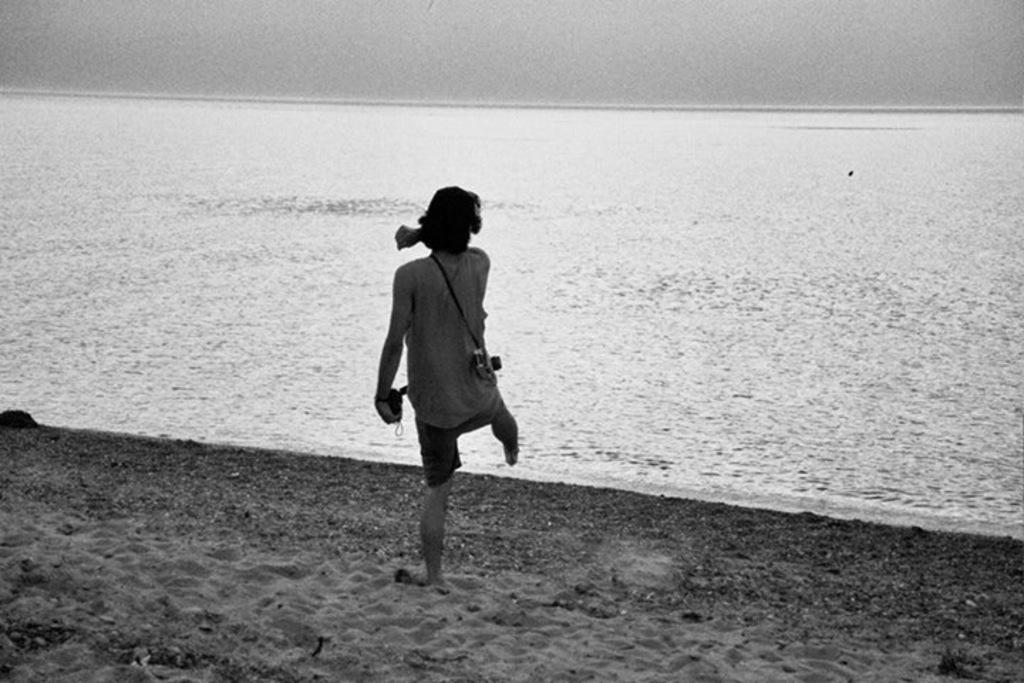What is the main subject in the foreground of the image? There is a man in the foreground of the image. What is the man wearing? The man is wearing a camera. What is the man holding in the image? The man is holding an object. How is the man positioned in the image? The man is standing on one foot. What type of surface is the man standing on? The man is standing on sand. What can be seen in the background of the image? There is water in the background of the image. What type of iron can be seen in the image? There is no iron present in the image. Can you tell me what receipt the man is holding in the image? The man is not holding a receipt in the image; he is holding an unspecified object. 